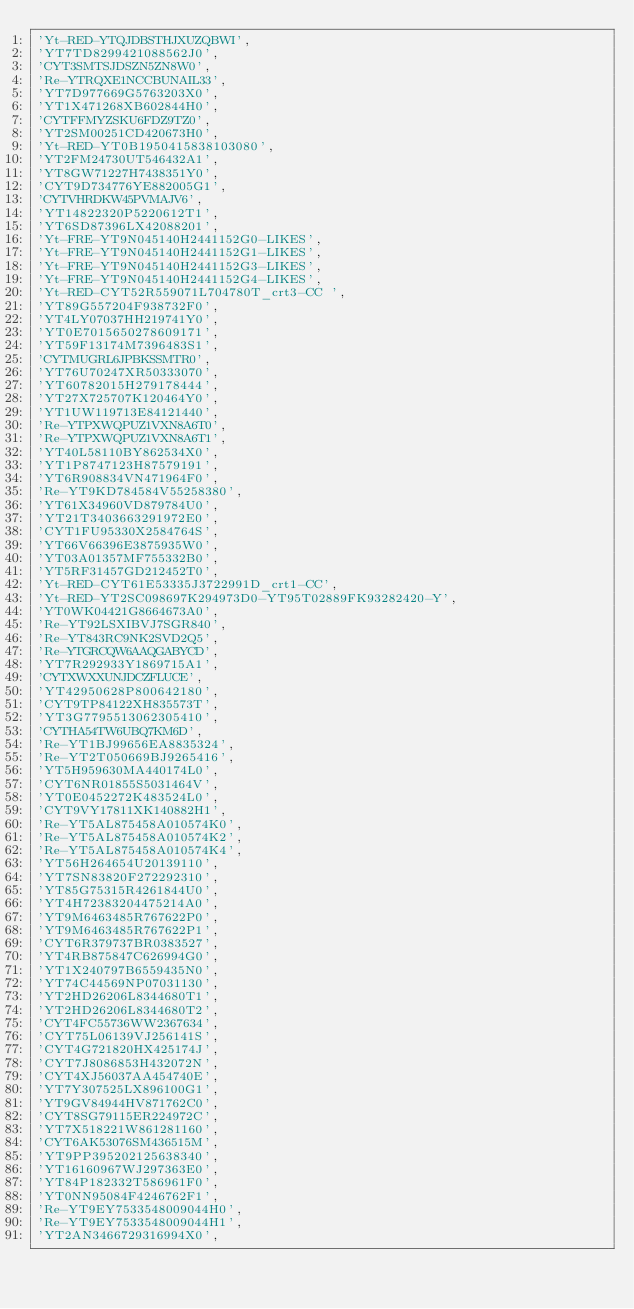Convert code to text. <code><loc_0><loc_0><loc_500><loc_500><_SQL_>'Yt-RED-YTQJDBSTHJXUZQBWI',
'YT7TD8299421088562J0',
'CYT3SMTSJDSZN5ZN8W0',
'Re-YTRQXE1NCCBUNAIL33',
'YT7D977669G5763203X0',
'YT1X471268XB602844H0',
'CYTFFMYZSKU6FDZ9TZ0',
'YT2SM00251CD420673H0',
'Yt-RED-YT0B1950415838103080',
'YT2FM24730UT546432A1',
'YT8GW71227H7438351Y0',
'CYT9D734776YE882005G1',
'CYTVHRDKW45PVMAJV6',
'YT14822320P5220612T1',
'YT6SD87396LX42088201',
'Yt-FRE-YT9N045140H2441152G0-LIKES',
'Yt-FRE-YT9N045140H2441152G1-LIKES',
'Yt-FRE-YT9N045140H2441152G3-LIKES',
'Yt-FRE-YT9N045140H2441152G4-LIKES',
'Yt-RED-CYT52R559071L704780T_crt3-CC ',
'YT89G557204F938732F0',
'YT4LY07037HH219741Y0',
'YT0E7015650278609171',
'YT59F13174M7396483S1',
'CYTMUGRL6JPBKSSMTR0',
'YT76U70247XR50333070',
'YT60782015H279178444',
'YT27X725707K120464Y0',
'YT1UW119713E84121440',
'Re-YTPXWQPUZ1VXN8A6T0',
'Re-YTPXWQPUZ1VXN8A6T1',
'YT40L58110BY862534X0',
'YT1P8747123H87579191',
'YT6R908834VN471964F0',
'Re-YT9KD784584V55258380',
'YT61X34960VD879784U0',
'YT21T3403663291972E0',
'CYT1FU95330X2584764S',
'YT66V66396E3875935W0',
'YT03A01357MF755332B0',
'YT5RF31457GD212452T0',
'Yt-RED-CYT61E53335J3722991D_crt1-CC',
'Yt-RED-YT2SC098697K294973D0-YT95T02889FK93282420-Y',
'YT0WK04421G8664673A0',
'Re-YT92LSXIBVJ7SGR840',
'Re-YT843RC9NK2SVD2Q5',
'Re-YTGRCQW6AAQGABYCD',
'YT7R292933Y1869715A1',
'CYTXWXXUNJDCZFLUCE',
'YT42950628P800642180',
'CYT9TP84122XH835573T',
'YT3G7795513062305410',
'CYTHA54TW6UBQ7KM6D',
'Re-YT1BJ99656EA8835324',
'Re-YT2T050669BJ9265416',
'YT5H959630MA440174L0',
'CYT6NR01855S5031464V',
'YT0E0452272K483524L0',
'CYT9VY17811XK140882H1',
'Re-YT5AL875458A010574K0',
'Re-YT5AL875458A010574K2',
'Re-YT5AL875458A010574K4',
'YT56H264654U20139110',
'YT7SN83820F272292310',
'YT85G75315R4261844U0',
'YT4H72383204475214A0',
'YT9M6463485R767622P0',
'YT9M6463485R767622P1',
'CYT6R379737BR0383527',
'YT4RB875847C626994G0',
'YT1X240797B6559435N0',
'YT74C44569NP07031130',
'YT2HD26206L8344680T1',
'YT2HD26206L8344680T2',
'CYT4FC55736WW2367634',
'CYT75L06139VJ256141S',
'CYT4G721820HX425174J',
'CYT7J8086853H432072N',
'CYT4XJ56037AA454740E',
'YT7Y307525LX896100G1',
'YT9GV84944HV871762C0',
'CYT8SG79115ER224972C',
'YT7X518221W861281160',
'CYT6AK53076SM436515M',
'YT9PP395202125638340',
'YT16160967WJ297363E0',
'YT84P182332T586961F0',
'YT0NN95084F4246762F1',
'Re-YT9EY7533548009044H0',
'Re-YT9EY7533548009044H1',
'YT2AN3466729316994X0',</code> 